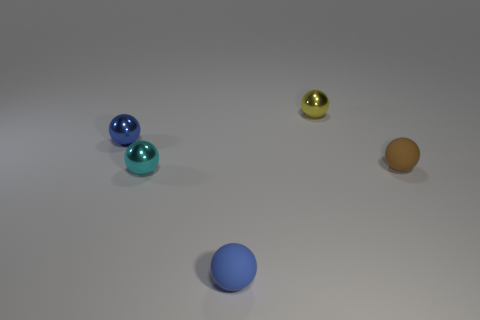Subtract all yellow cylinders. How many blue balls are left? 2 Subtract all blue spheres. How many spheres are left? 3 Subtract 3 spheres. How many spheres are left? 2 Add 2 yellow metal spheres. How many objects exist? 7 Subtract all brown balls. How many balls are left? 4 Subtract all cyan balls. Subtract all green cubes. How many balls are left? 4 Subtract all small metal spheres. Subtract all small purple balls. How many objects are left? 2 Add 3 blue rubber objects. How many blue rubber objects are left? 4 Add 4 brown things. How many brown things exist? 5 Subtract 0 red cylinders. How many objects are left? 5 